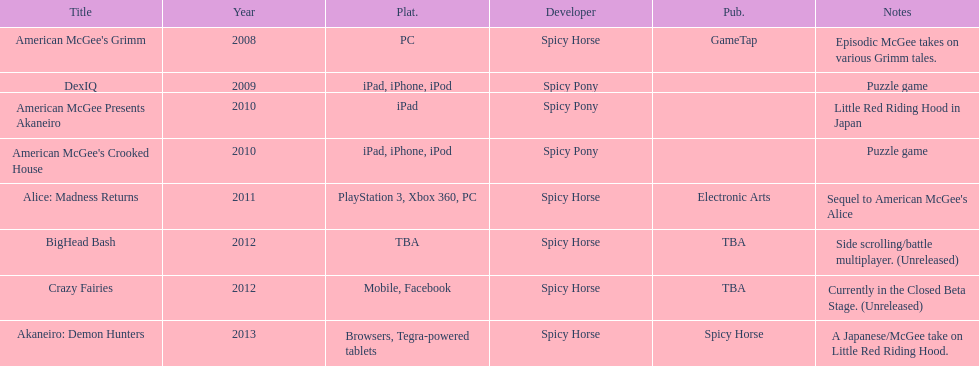What is the first title on this chart? American McGee's Grimm. 